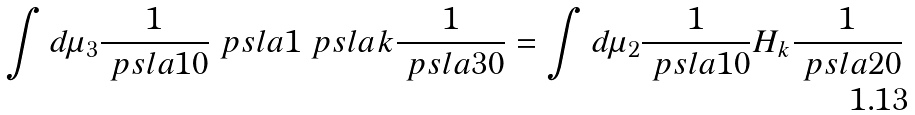Convert formula to latex. <formula><loc_0><loc_0><loc_500><loc_500>\int d \mu _ { 3 } \frac { 1 } { \ p s l a { 1 0 } } \ p s l a 1 \ p s l a { k } \frac { 1 } { \ p s l a { 3 0 } } = \int d \mu _ { 2 } \frac { 1 } { \ p s l a { 1 0 } } H _ { k } \frac { 1 } { \ p s l a { 2 0 } }</formula> 